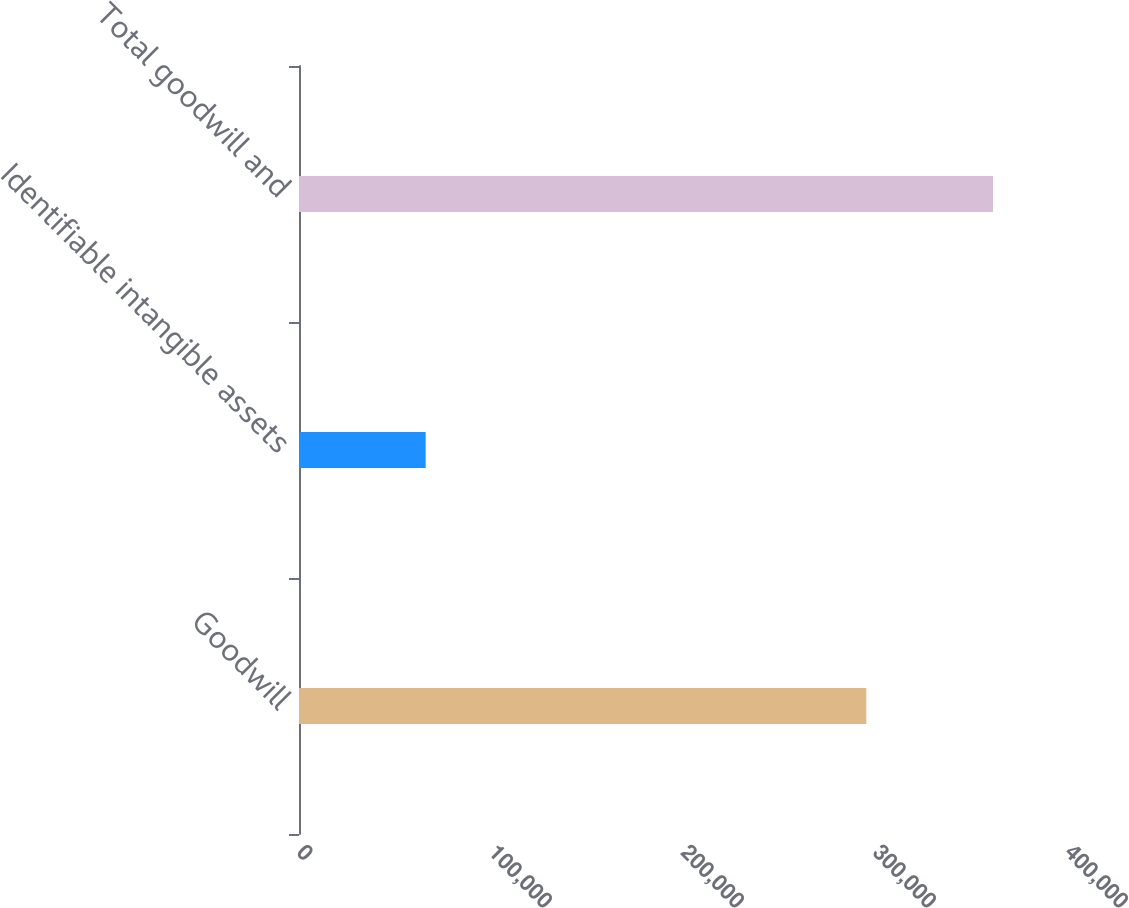Convert chart to OTSL. <chart><loc_0><loc_0><loc_500><loc_500><bar_chart><fcel>Goodwill<fcel>Identifiable intangible assets<fcel>Total goodwill and<nl><fcel>295486<fcel>65978<fcel>361464<nl></chart> 